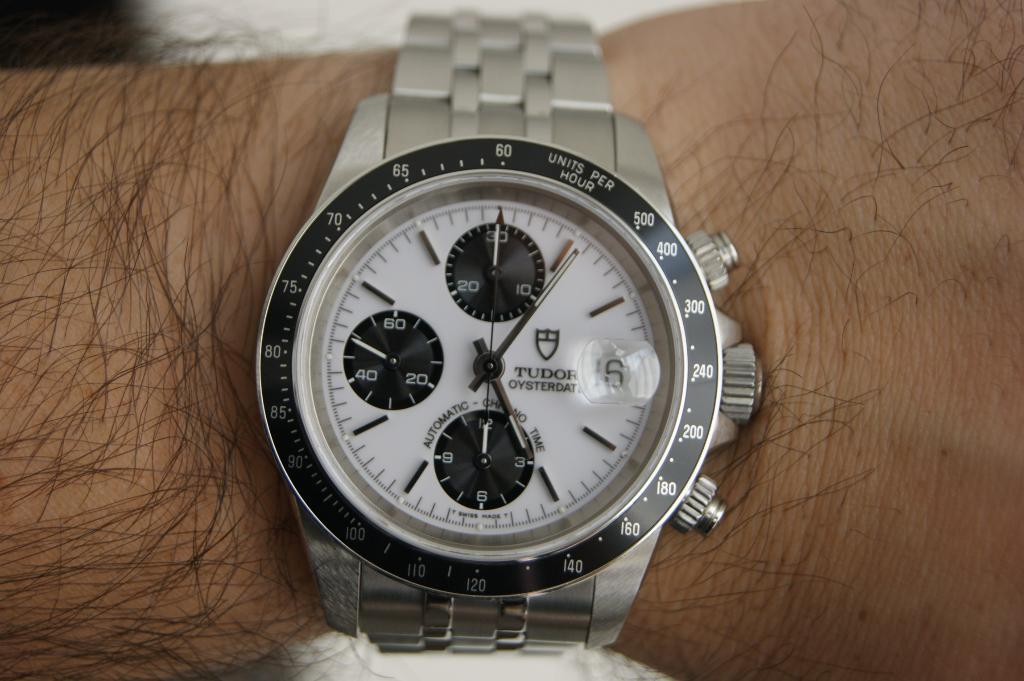<image>
Create a compact narrative representing the image presented. A man is wearing a silver Tudor watch on his arm. 